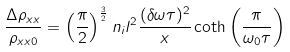<formula> <loc_0><loc_0><loc_500><loc_500>\frac { \Delta \rho _ { x x } } { \rho _ { x x 0 } } = \left ( \frac { \pi } { 2 } \right ) ^ { \frac { 3 } { 2 } } n _ { i } l ^ { 2 } \frac { ( \delta \omega \tau ) ^ { 2 } } { x } \coth \left ( \frac { \pi } { \omega _ { 0 } \tau } \right )</formula> 